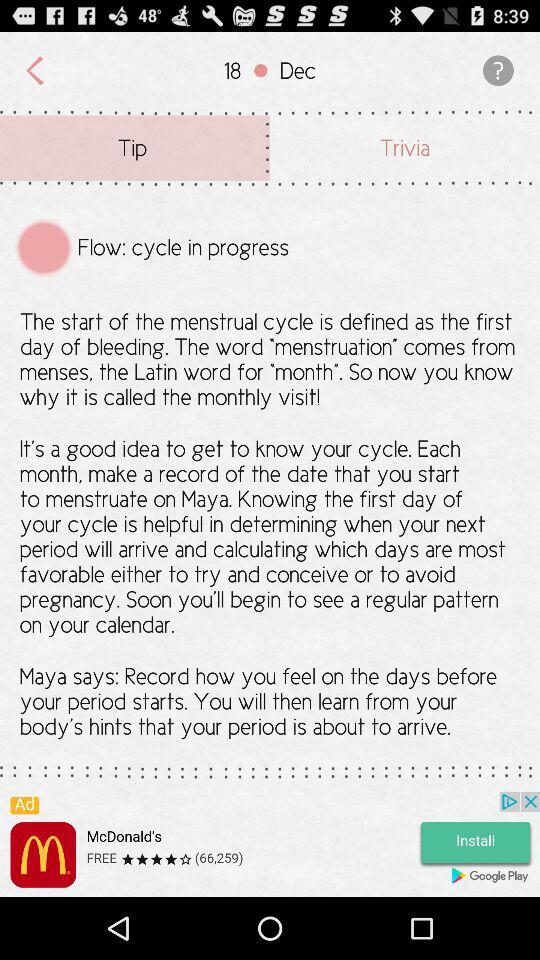What is the date? The date is December 20. 